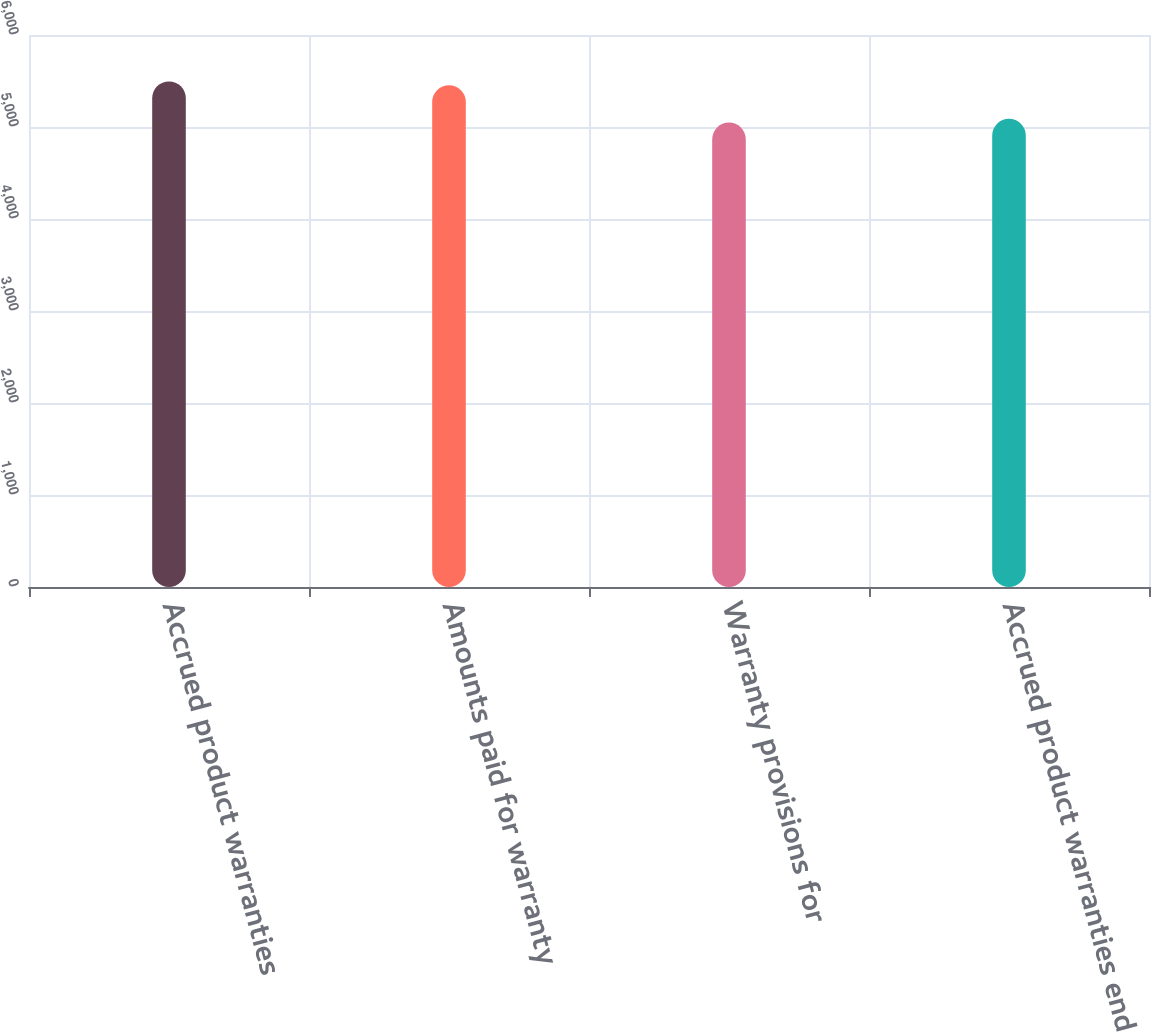Convert chart. <chart><loc_0><loc_0><loc_500><loc_500><bar_chart><fcel>Accrued product warranties<fcel>Amounts paid for warranty<fcel>Warranty provisions for<fcel>Accrued product warranties end<nl><fcel>5495.7<fcel>5454<fcel>5048<fcel>5089.7<nl></chart> 